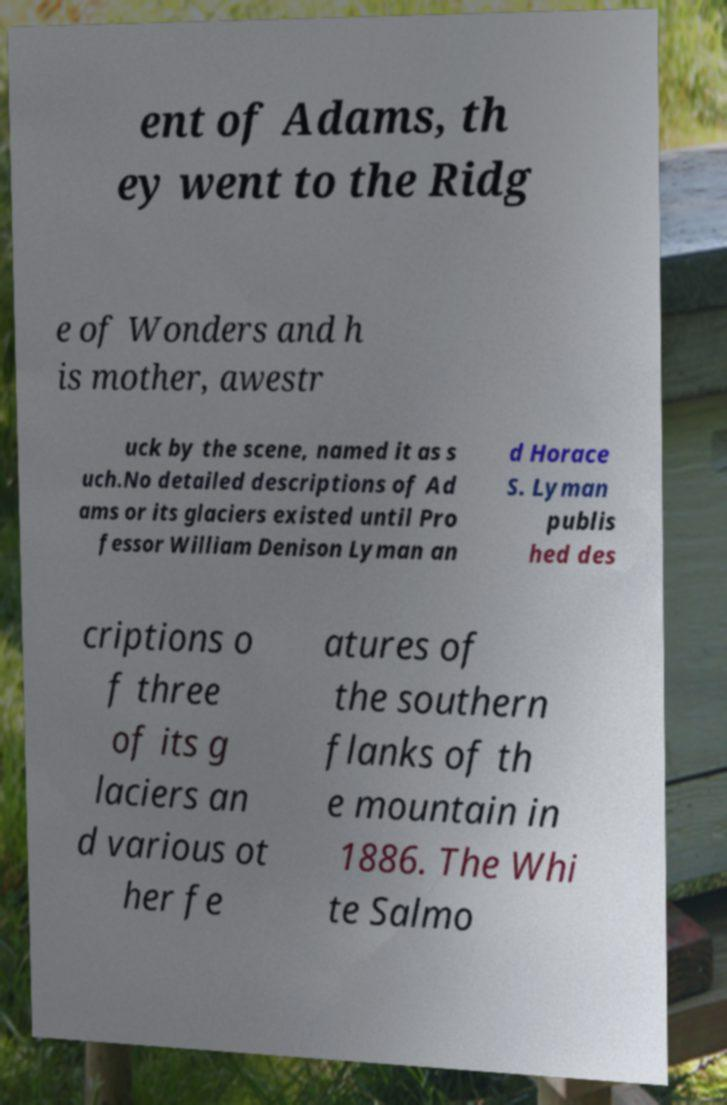Can you accurately transcribe the text from the provided image for me? ent of Adams, th ey went to the Ridg e of Wonders and h is mother, awestr uck by the scene, named it as s uch.No detailed descriptions of Ad ams or its glaciers existed until Pro fessor William Denison Lyman an d Horace S. Lyman publis hed des criptions o f three of its g laciers an d various ot her fe atures of the southern flanks of th e mountain in 1886. The Whi te Salmo 